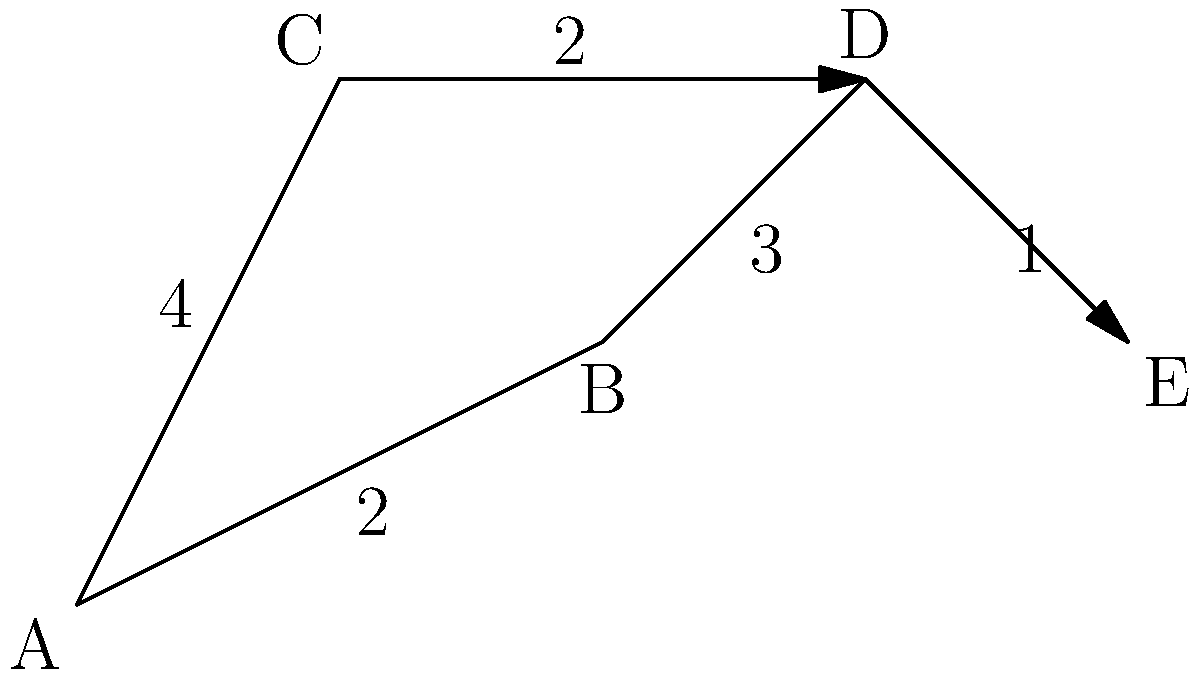In the Battle of Normandy, efficient supply lines were crucial. The diagram represents a network of roads connecting supply points A to E. The numbers on each edge represent the time (in hours) required to traverse that road. What is the minimum time required to transport supplies from point A to point E? To find the minimum time required to transport supplies from point A to point E, we need to find the shortest path in the network. We can use the following steps:

1. Identify all possible paths from A to E:
   Path 1: A → B → D → E
   Path 2: A → C → D → E

2. Calculate the total time for each path:
   Path 1: A → B (2 hours) + B → D (3 hours) + D → E (1 hour) = 6 hours
   Path 2: A → C (4 hours) + C → D (2 hours) + D → E (1 hour) = 7 hours

3. Compare the total times:
   Path 1 takes 6 hours
   Path 2 takes 7 hours

4. Select the path with the minimum time:
   Path 1 (A → B → D → E) is the shortest, taking 6 hours.

Therefore, the minimum time required to transport supplies from point A to point E is 6 hours.
Answer: 6 hours 